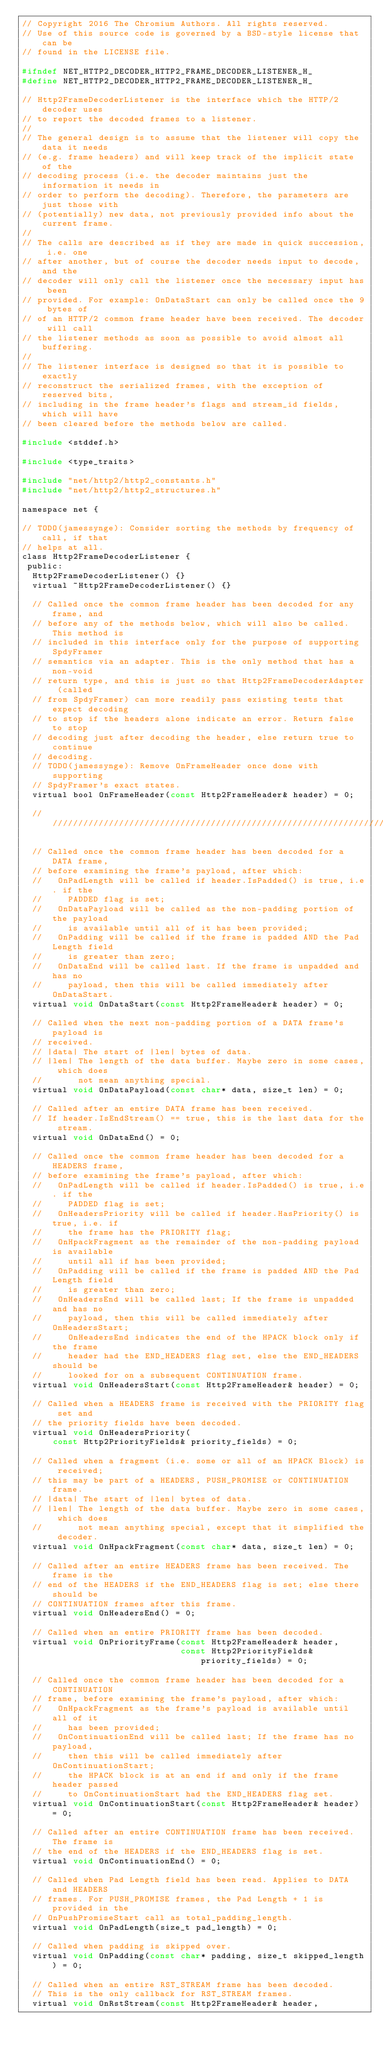Convert code to text. <code><loc_0><loc_0><loc_500><loc_500><_C_>// Copyright 2016 The Chromium Authors. All rights reserved.
// Use of this source code is governed by a BSD-style license that can be
// found in the LICENSE file.

#ifndef NET_HTTP2_DECODER_HTTP2_FRAME_DECODER_LISTENER_H_
#define NET_HTTP2_DECODER_HTTP2_FRAME_DECODER_LISTENER_H_

// Http2FrameDecoderListener is the interface which the HTTP/2 decoder uses
// to report the decoded frames to a listener.
//
// The general design is to assume that the listener will copy the data it needs
// (e.g. frame headers) and will keep track of the implicit state of the
// decoding process (i.e. the decoder maintains just the information it needs in
// order to perform the decoding). Therefore, the parameters are just those with
// (potentially) new data, not previously provided info about the current frame.
//
// The calls are described as if they are made in quick succession, i.e. one
// after another, but of course the decoder needs input to decode, and the
// decoder will only call the listener once the necessary input has been
// provided. For example: OnDataStart can only be called once the 9 bytes of
// of an HTTP/2 common frame header have been received. The decoder will call
// the listener methods as soon as possible to avoid almost all buffering.
//
// The listener interface is designed so that it is possible to exactly
// reconstruct the serialized frames, with the exception of reserved bits,
// including in the frame header's flags and stream_id fields, which will have
// been cleared before the methods below are called.

#include <stddef.h>

#include <type_traits>

#include "net/http2/http2_constants.h"
#include "net/http2/http2_structures.h"

namespace net {

// TODO(jamessynge): Consider sorting the methods by frequency of call, if that
// helps at all.
class Http2FrameDecoderListener {
 public:
  Http2FrameDecoderListener() {}
  virtual ~Http2FrameDecoderListener() {}

  // Called once the common frame header has been decoded for any frame, and
  // before any of the methods below, which will also be called. This method is
  // included in this interface only for the purpose of supporting SpdyFramer
  // semantics via an adapter. This is the only method that has a non-void
  // return type, and this is just so that Http2FrameDecoderAdapter (called
  // from SpdyFramer) can more readily pass existing tests that expect decoding
  // to stop if the headers alone indicate an error. Return false to stop
  // decoding just after decoding the header, else return true to continue
  // decoding.
  // TODO(jamessynge): Remove OnFrameHeader once done with supporting
  // SpdyFramer's exact states.
  virtual bool OnFrameHeader(const Http2FrameHeader& header) = 0;

  //////////////////////////////////////////////////////////////////////////////

  // Called once the common frame header has been decoded for a DATA frame,
  // before examining the frame's payload, after which:
  //   OnPadLength will be called if header.IsPadded() is true, i.e. if the
  //     PADDED flag is set;
  //   OnDataPayload will be called as the non-padding portion of the payload
  //     is available until all of it has been provided;
  //   OnPadding will be called if the frame is padded AND the Pad Length field
  //     is greater than zero;
  //   OnDataEnd will be called last. If the frame is unpadded and has no
  //     payload, then this will be called immediately after OnDataStart.
  virtual void OnDataStart(const Http2FrameHeader& header) = 0;

  // Called when the next non-padding portion of a DATA frame's payload is
  // received.
  // |data| The start of |len| bytes of data.
  // |len| The length of the data buffer. Maybe zero in some cases, which does
  //       not mean anything special.
  virtual void OnDataPayload(const char* data, size_t len) = 0;

  // Called after an entire DATA frame has been received.
  // If header.IsEndStream() == true, this is the last data for the stream.
  virtual void OnDataEnd() = 0;

  // Called once the common frame header has been decoded for a HEADERS frame,
  // before examining the frame's payload, after which:
  //   OnPadLength will be called if header.IsPadded() is true, i.e. if the
  //     PADDED flag is set;
  //   OnHeadersPriority will be called if header.HasPriority() is true, i.e. if
  //     the frame has the PRIORITY flag;
  //   OnHpackFragment as the remainder of the non-padding payload is available
  //     until all if has been provided;
  //   OnPadding will be called if the frame is padded AND the Pad Length field
  //     is greater than zero;
  //   OnHeadersEnd will be called last; If the frame is unpadded and has no
  //     payload, then this will be called immediately after OnHeadersStart;
  //     OnHeadersEnd indicates the end of the HPACK block only if the frame
  //     header had the END_HEADERS flag set, else the END_HEADERS should be
  //     looked for on a subsequent CONTINUATION frame.
  virtual void OnHeadersStart(const Http2FrameHeader& header) = 0;

  // Called when a HEADERS frame is received with the PRIORITY flag set and
  // the priority fields have been decoded.
  virtual void OnHeadersPriority(
      const Http2PriorityFields& priority_fields) = 0;

  // Called when a fragment (i.e. some or all of an HPACK Block) is received;
  // this may be part of a HEADERS, PUSH_PROMISE or CONTINUATION frame.
  // |data| The start of |len| bytes of data.
  // |len| The length of the data buffer. Maybe zero in some cases, which does
  //       not mean anything special, except that it simplified the decoder.
  virtual void OnHpackFragment(const char* data, size_t len) = 0;

  // Called after an entire HEADERS frame has been received. The frame is the
  // end of the HEADERS if the END_HEADERS flag is set; else there should be
  // CONTINUATION frames after this frame.
  virtual void OnHeadersEnd() = 0;

  // Called when an entire PRIORITY frame has been decoded.
  virtual void OnPriorityFrame(const Http2FrameHeader& header,
                               const Http2PriorityFields& priority_fields) = 0;

  // Called once the common frame header has been decoded for a CONTINUATION
  // frame, before examining the frame's payload, after which:
  //   OnHpackFragment as the frame's payload is available until all of it
  //     has been provided;
  //   OnContinuationEnd will be called last; If the frame has no payload,
  //     then this will be called immediately after OnContinuationStart;
  //     the HPACK block is at an end if and only if the frame header passed
  //     to OnContinuationStart had the END_HEADERS flag set.
  virtual void OnContinuationStart(const Http2FrameHeader& header) = 0;

  // Called after an entire CONTINUATION frame has been received. The frame is
  // the end of the HEADERS if the END_HEADERS flag is set.
  virtual void OnContinuationEnd() = 0;

  // Called when Pad Length field has been read. Applies to DATA and HEADERS
  // frames. For PUSH_PROMISE frames, the Pad Length + 1 is provided in the
  // OnPushPromiseStart call as total_padding_length.
  virtual void OnPadLength(size_t pad_length) = 0;

  // Called when padding is skipped over.
  virtual void OnPadding(const char* padding, size_t skipped_length) = 0;

  // Called when an entire RST_STREAM frame has been decoded.
  // This is the only callback for RST_STREAM frames.
  virtual void OnRstStream(const Http2FrameHeader& header,</code> 